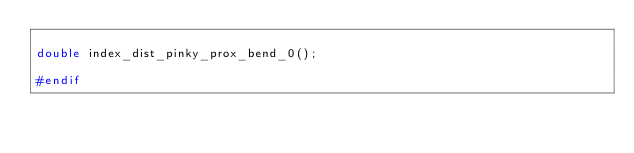Convert code to text. <code><loc_0><loc_0><loc_500><loc_500><_C_>
double index_dist_pinky_prox_bend_0();

#endif

</code> 